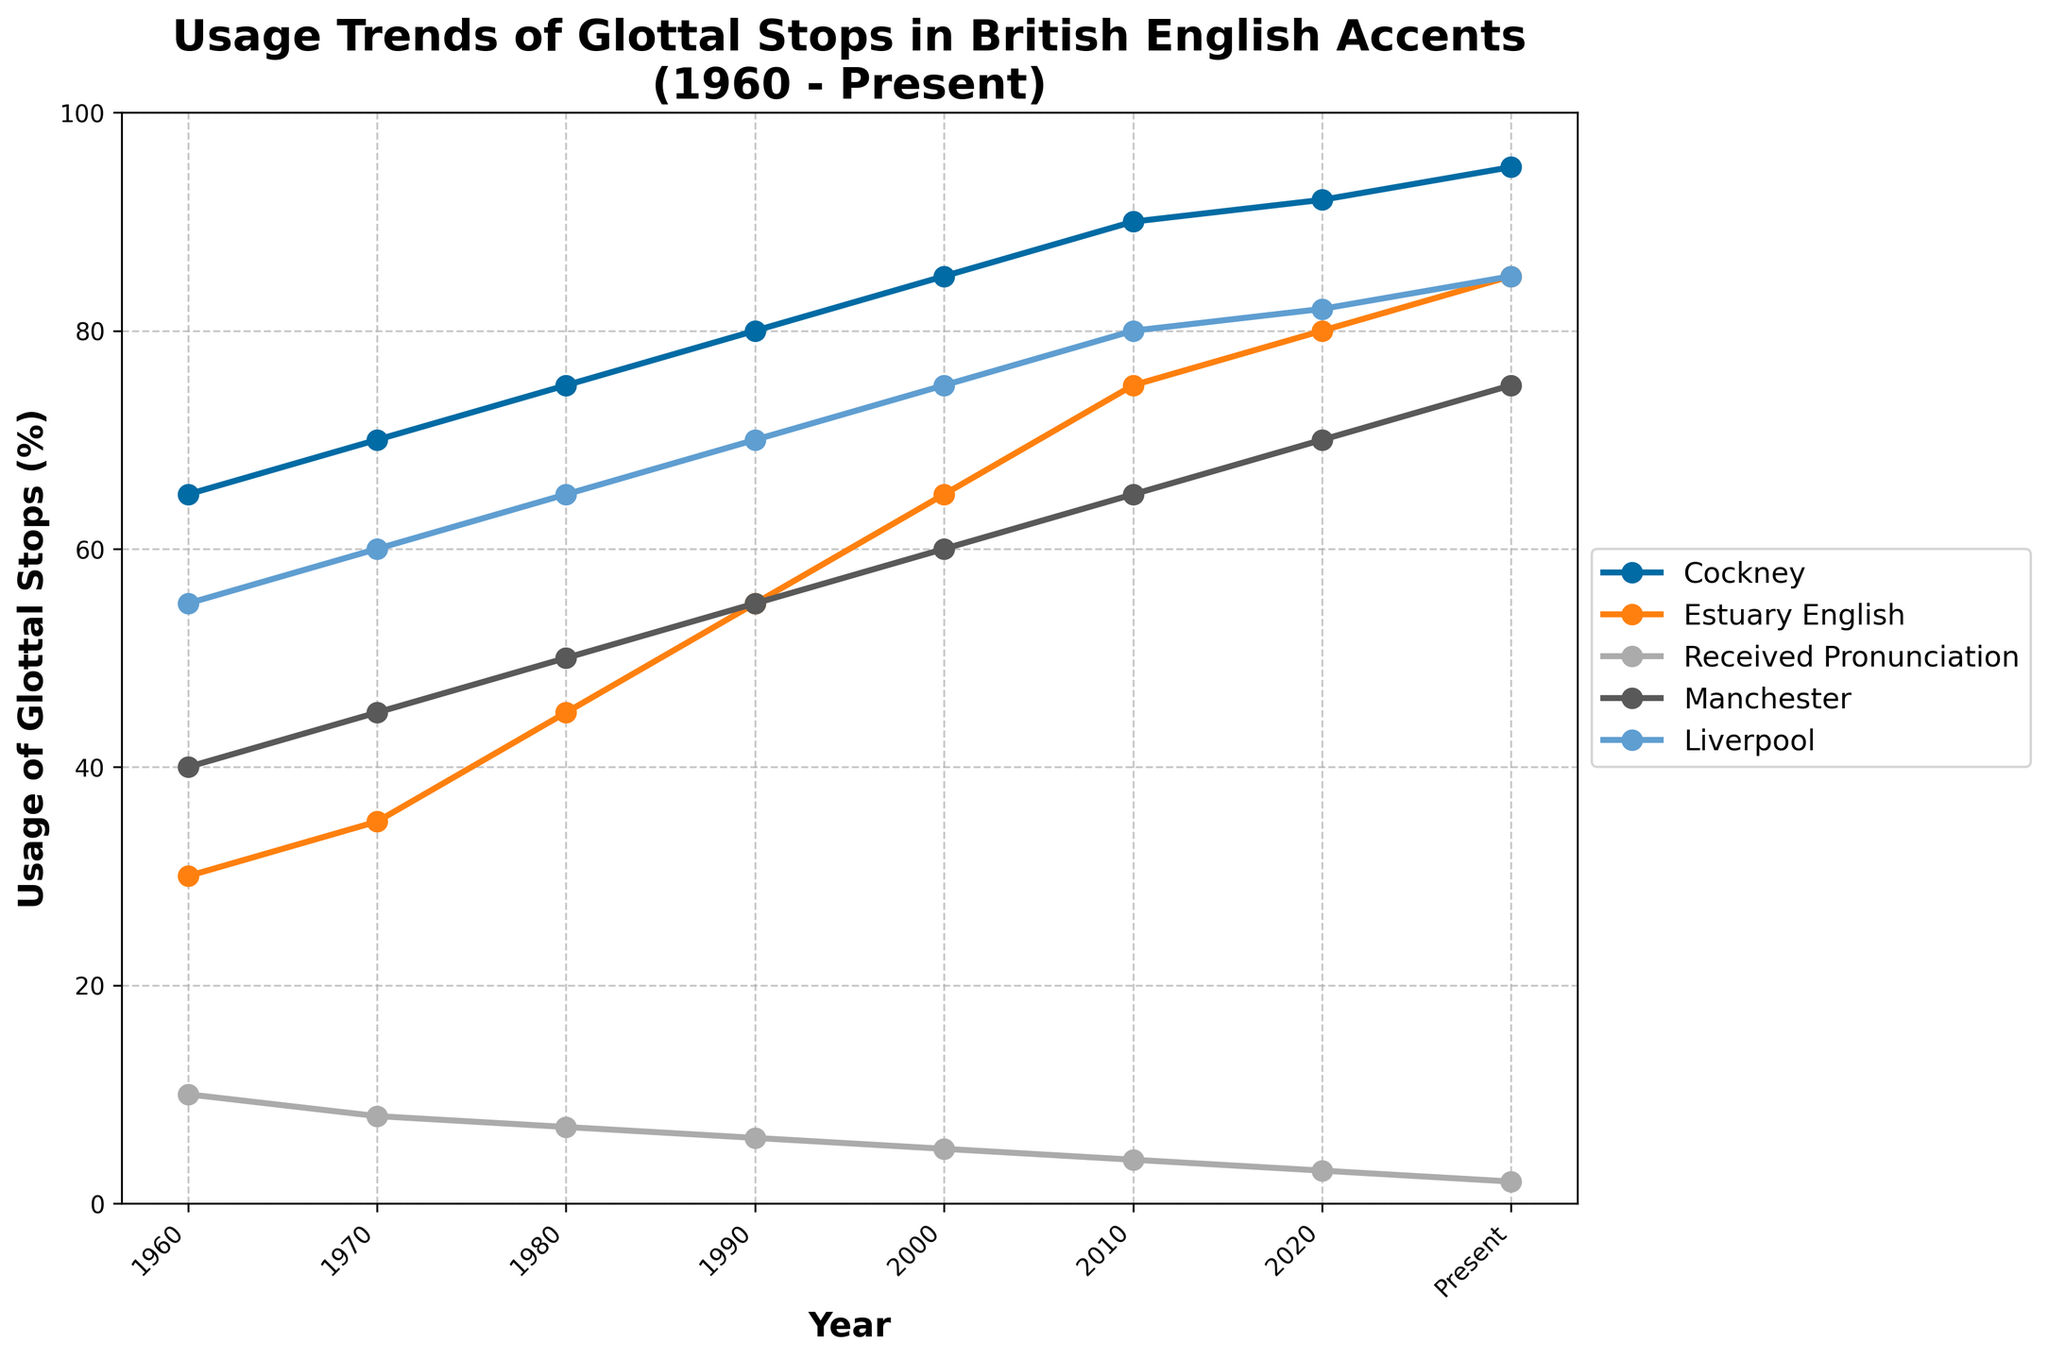what is the general trend in the usage of glottal stops in Cockney from 1960 to present? The series for Cockney shows a clear upward trend from 1960 (65%) to the present (95%), indicating a consistent increase in the usage of glottal stops over the years.
Answer: Increasing Which accent had the lowest usage of glottal stops in 2020? By examining the data points for 2020, the Received Pronunciation shows 3%, which is the lowest among all the accents listed.
Answer: Received Pronunciation How much did the usage of glottal stops in Estuary English increase from 1970 to 1990? The usage in Estuary English in 1970 was 35%, and it increased to 55% by 1990. The difference between these two points is 55 - 35 = 20%.
Answer: 20% Is there any accent that has a periodic decline in the usage of glottal stops? None of the plotted accents exhibit a periodic decline in their usage of glottal stops. All accents show either a consistent increase or remain relatively stable.
Answer: No What is the visual difference between the trend lines for Cockney and Manchester accents? The Cockney accent trend line starts higher and shows a steeper and more continuous increase to the highest usage, while the Manchester accent starts moderate and shows a slower but consistent increase, remaining lower than Cockney at every point.
Answer: Cockney has a steeper increase Which year did Liverpool surpass the 70% mark in the usage of glottal stops? The Liverpool trend line surpasses the 70% mark between 2000 (75%) and 2010 (80%). The year when it first crosses is 2000.
Answer: 2000 Compare the usage of glottal stops in Received Pronunciation with Cockney in 1980. In 1980, Received Pronunciation has 7% usage of glottal stops while Cockney has 75%. This shows a substantial difference of 68% between the two.
Answer: Cockney is 68% higher During which periods do the Estuary English and Liverpool lines show the same growth pattern? Both Estuary English and Liverpool show an increased growth from 1960 to present; however, they distinctly show similar increments between each decade points starting from 1960 to 2020, each showing consistent upward trends.
Answer: From 1960 to present with consistent increments What's the overall change in the usage of glottal stops in Manchester from 1960 to present, and what percentage does it represent? The usage in Manchester was 40% in 1960, and increased to 75% in the present. The overall change is 75 - 40 = 35%. To find the percentage change: (35 / 40) * 100 = 87.5%.
Answer: Increase by 35%, 87.5% change What is the ranking of accents by their usage of glottal stops in 2010? The usage percentages in 2010 are: Cockney (90%), Estuary English (75%), Liverpool (80%), Manchester (65%), and Received Pronunciation (4%). Ranking from highest to lowest is: Cockney, Liverpool, Estuary English, Manchester, Received Pronunciation.
Answer: Cockney > Liverpool > Estuary English > Manchester > Received Pronunciation 